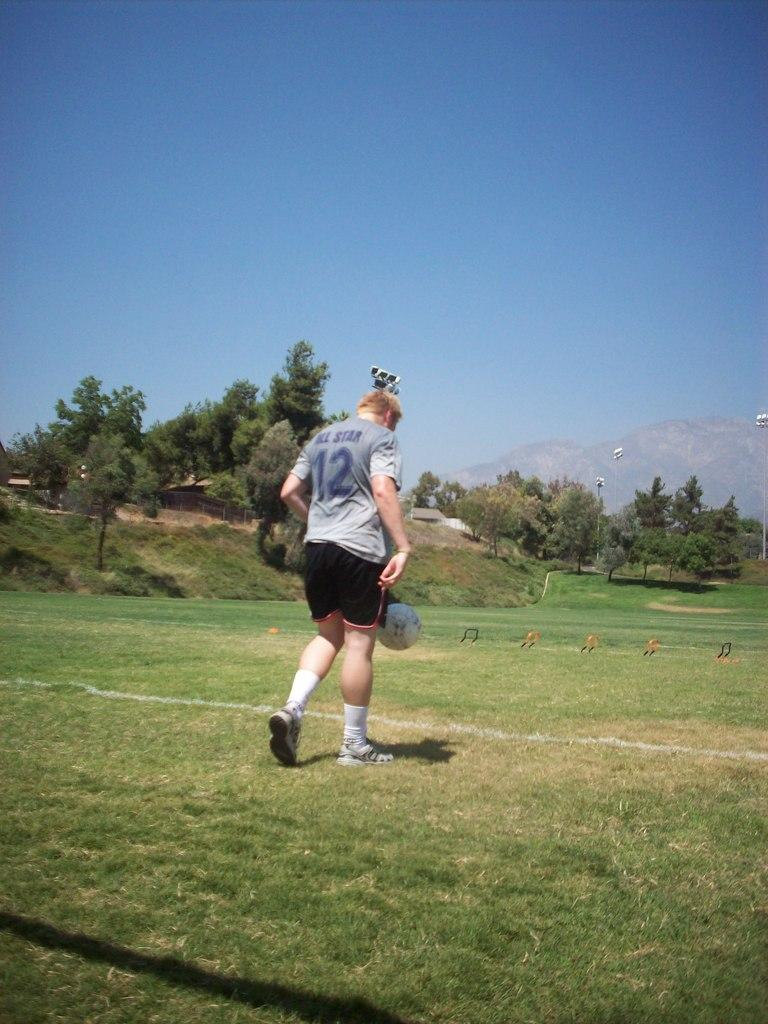<image>
Summarize the visual content of the image. A girl has a shirt with the word star on the back. 